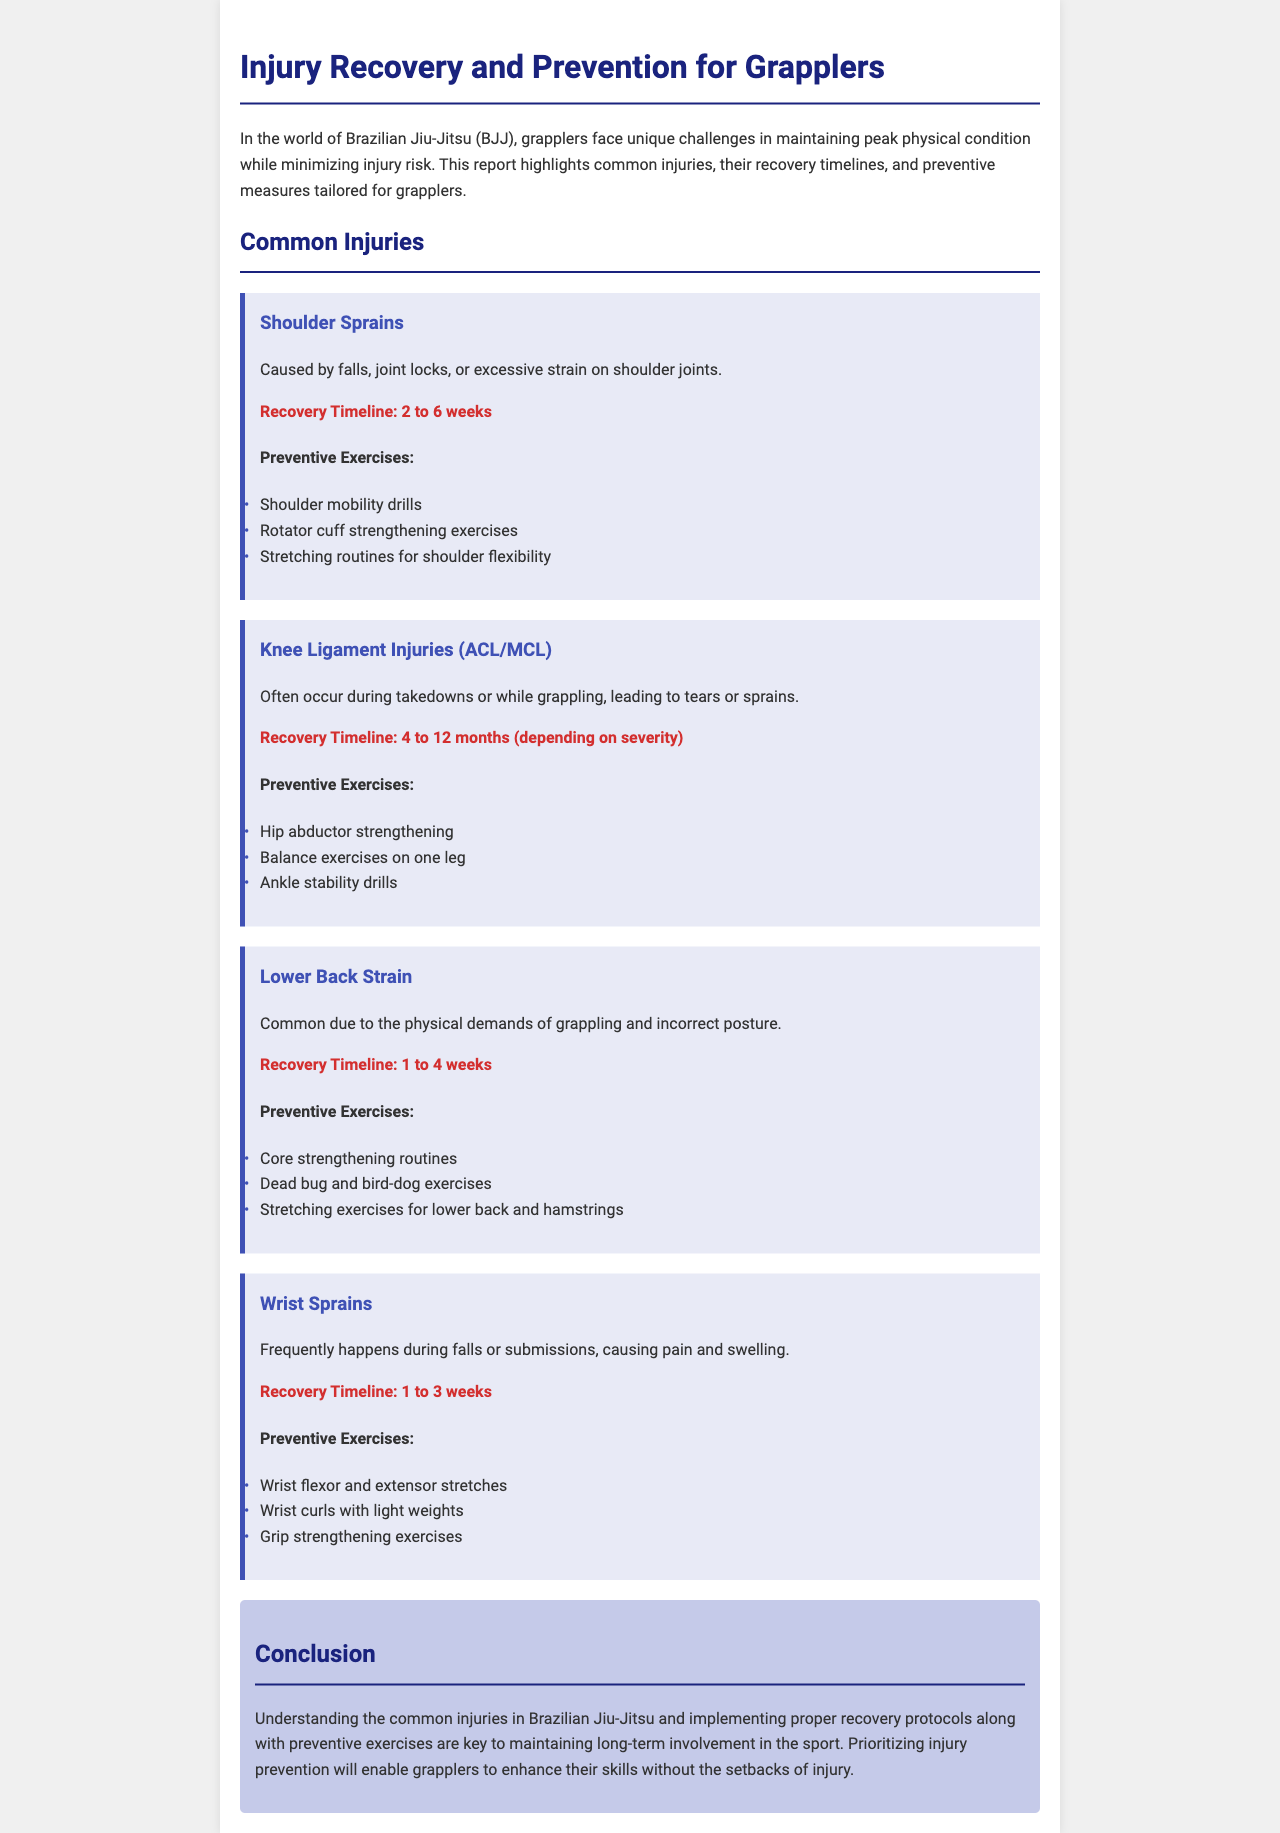What is the recovery timeline for shoulder sprains? The recovery timeline for shoulder sprains is provided in the document under the injury section for shoulder sprains.
Answer: 2 to 6 weeks What preventive exercise is recommended for knee ligament injuries? The document lists specific preventive exercises for knee ligament injuries, including hip abductor strengthening.
Answer: Hip abductor strengthening How long can recovery take for knee ligament injuries? The document specifies the recovery timeline for knee ligament injuries (ACL/MCL) in months based on severity.
Answer: 4 to 12 months What type of injury is caused by incorrect posture during grappling? The document discusses lower back strain as a common injury related to posture in grappling.
Answer: Lower Back Strain How many weeks is the recovery timeline for wrist sprains? The document details the recovery timeline specifically for wrist sprains within its injury section.
Answer: 1 to 3 weeks What is a suggested preventive exercise for shoulder flexibility? The document lists several preventive exercises for shoulder sprains, including one specifically for flexibility.
Answer: Stretching routines for shoulder flexibility What is the main focus of the report? The overall aim of the report is stated in the introduction, covering injury recovery and prevention insights for grapplers.
Answer: Injury Recovery and Prevention Which exercise is recommended for core strengthening? The document provides specific core strengthening routines among preventive exercises for lower back strain.
Answer: Core strengthening routines 